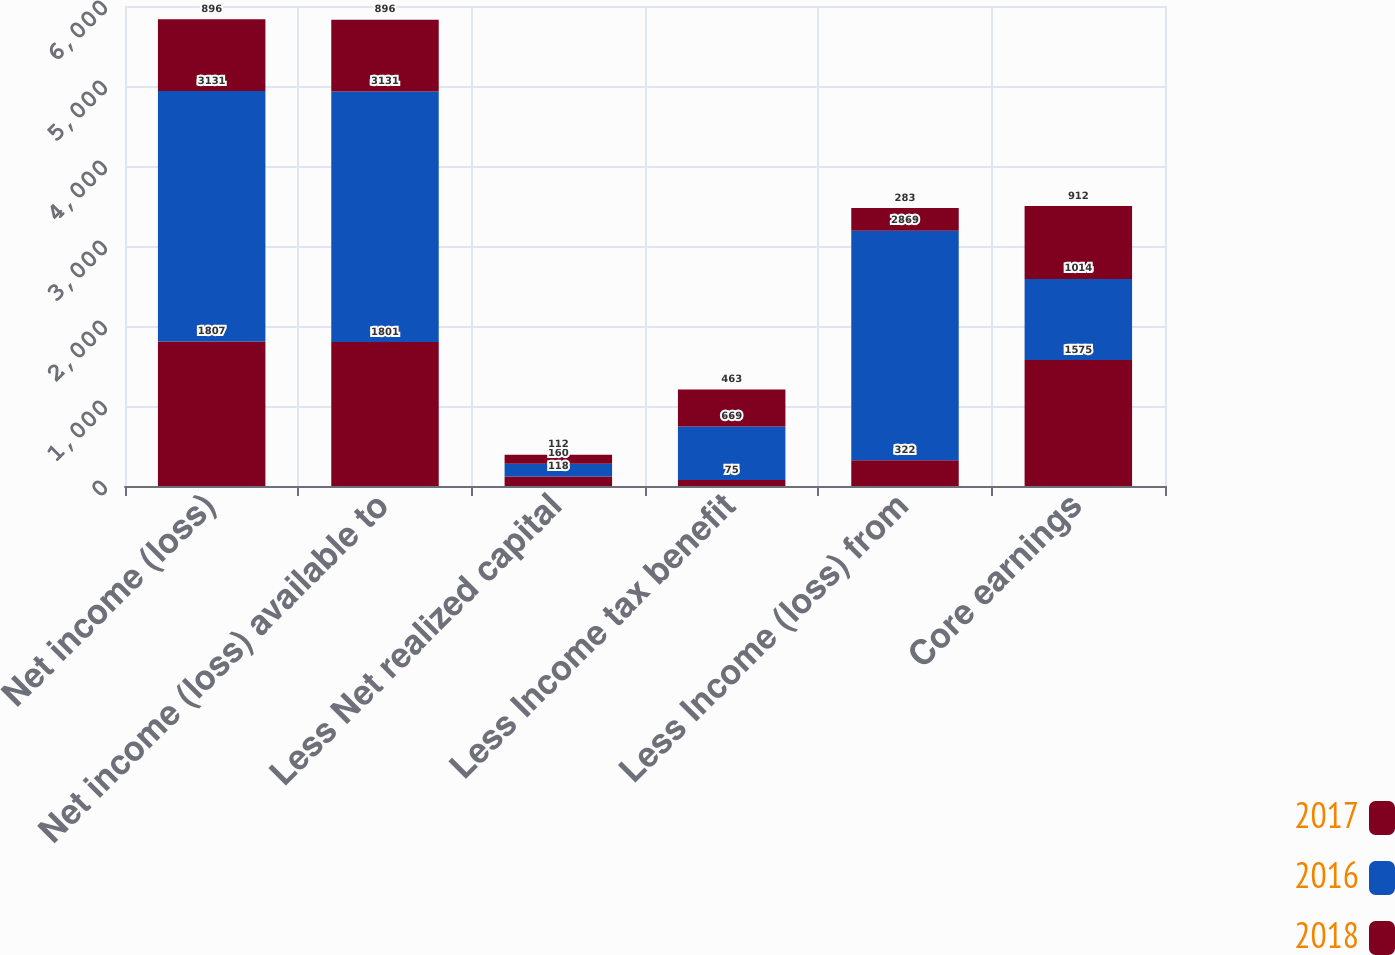Convert chart to OTSL. <chart><loc_0><loc_0><loc_500><loc_500><stacked_bar_chart><ecel><fcel>Net income (loss)<fcel>Net income (loss) available to<fcel>Less Net realized capital<fcel>Less Income tax benefit<fcel>Less Income (loss) from<fcel>Core earnings<nl><fcel>2017<fcel>1807<fcel>1801<fcel>118<fcel>75<fcel>322<fcel>1575<nl><fcel>2016<fcel>3131<fcel>3131<fcel>160<fcel>669<fcel>2869<fcel>1014<nl><fcel>2018<fcel>896<fcel>896<fcel>112<fcel>463<fcel>283<fcel>912<nl></chart> 